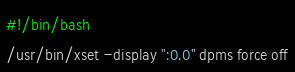Convert code to text. <code><loc_0><loc_0><loc_500><loc_500><_Bash_>#!/bin/bash
/usr/bin/xset -display ":0.0" dpms force off
</code> 